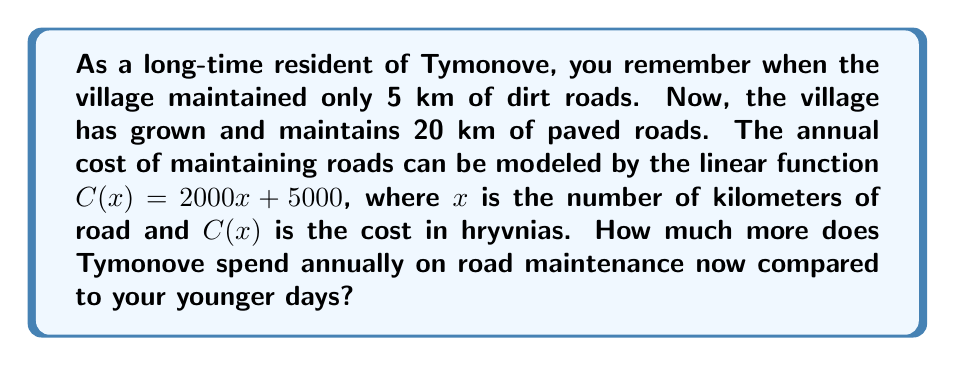Provide a solution to this math problem. To solve this problem, we need to:
1. Calculate the cost of maintaining 5 km of roads (past)
2. Calculate the cost of maintaining 20 km of roads (present)
3. Find the difference between these two costs

Step 1: Cost of maintaining 5 km of roads
$$C(5) = 2000(5) + 5000 = 10000 + 5000 = 15000\text{ hryvnias}$$

Step 2: Cost of maintaining 20 km of roads
$$C(20) = 2000(20) + 5000 = 40000 + 5000 = 45000\text{ hryvnias}$$

Step 3: Difference in cost
$$45000 - 15000 = 30000\text{ hryvnias}$$

Therefore, Tymonove spends 30000 hryvnias more annually on road maintenance now compared to the past.
Answer: 30000 hryvnias 